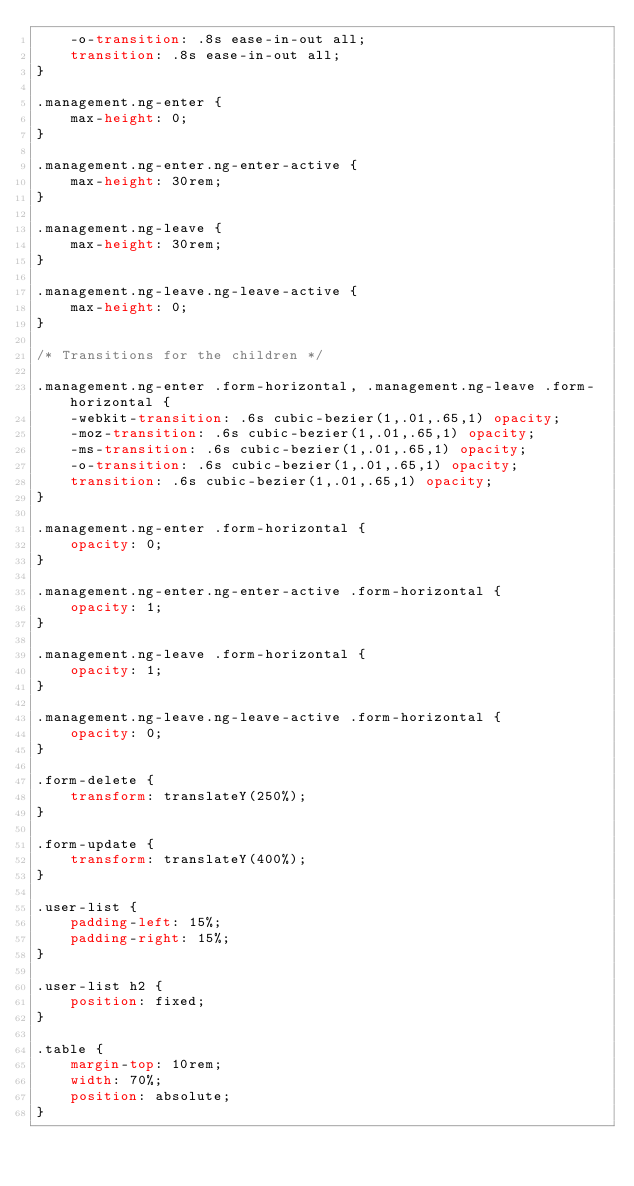<code> <loc_0><loc_0><loc_500><loc_500><_CSS_>	-o-transition: .8s ease-in-out all;
	transition: .8s ease-in-out all;
}

.management.ng-enter {
	max-height: 0;
}

.management.ng-enter.ng-enter-active {
	max-height: 30rem;
}

.management.ng-leave {
	max-height: 30rem;
}

.management.ng-leave.ng-leave-active {
	max-height: 0;	
}

/* Transitions for the children */

.management.ng-enter .form-horizontal, .management.ng-leave .form-horizontal {
	-webkit-transition: .6s cubic-bezier(1,.01,.65,1) opacity;
	-moz-transition: .6s cubic-bezier(1,.01,.65,1) opacity;
	-ms-transition: .6s cubic-bezier(1,.01,.65,1) opacity;
	-o-transition: .6s cubic-bezier(1,.01,.65,1) opacity;
	transition: .6s cubic-bezier(1,.01,.65,1) opacity;
}

.management.ng-enter .form-horizontal {
	opacity: 0;
}

.management.ng-enter.ng-enter-active .form-horizontal {
	opacity: 1;
}

.management.ng-leave .form-horizontal {
	opacity: 1;
}

.management.ng-leave.ng-leave-active .form-horizontal {
	opacity: 0;	
}

.form-delete {
	transform: translateY(250%);
}

.form-update {
	transform: translateY(400%);
}

.user-list {
	padding-left: 15%;
	padding-right: 15%;
}

.user-list h2 {
	position: fixed;
}

.table {
	margin-top: 10rem;
	width: 70%;
	position: absolute;
}
</code> 